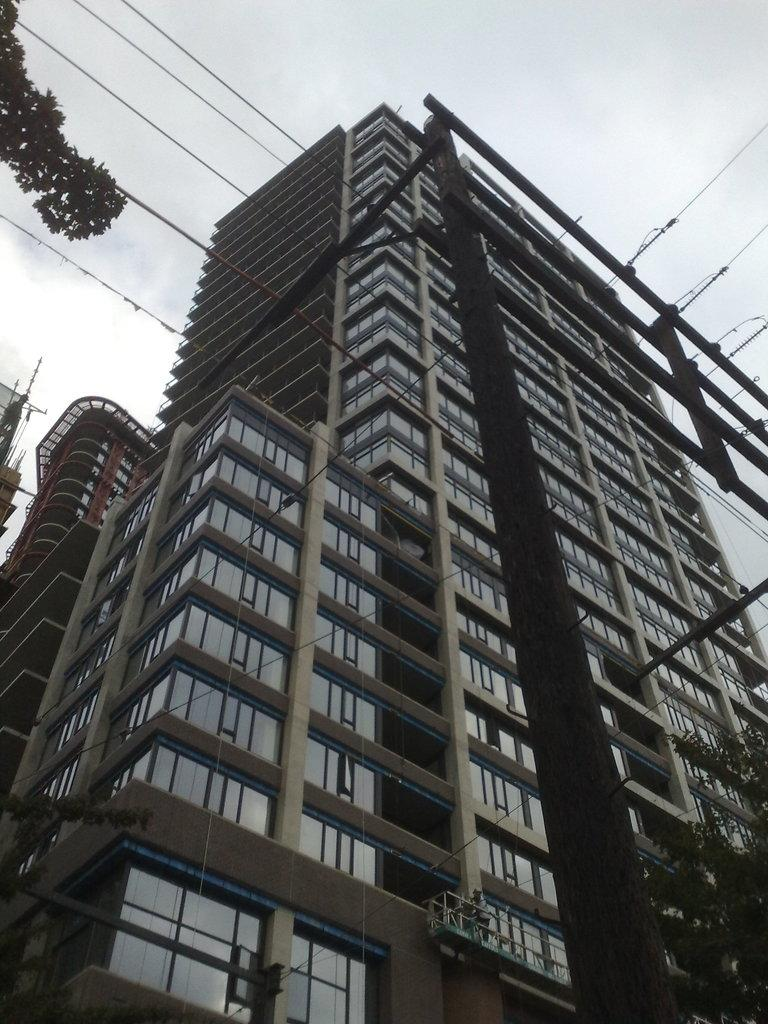What type of tall building is present in the image? There is a skyscraper in the image. What is located in front of the skyscraper? There is a tree in front of the skyscraper. What can be seen above the skyscraper? The sky is visible above the skyscraper. Where is the pot of cakes located in the image? There is no pot of cakes present in the image. What type of creature is seen basking in the sun in the image? There is no creature or sun present in the image. 